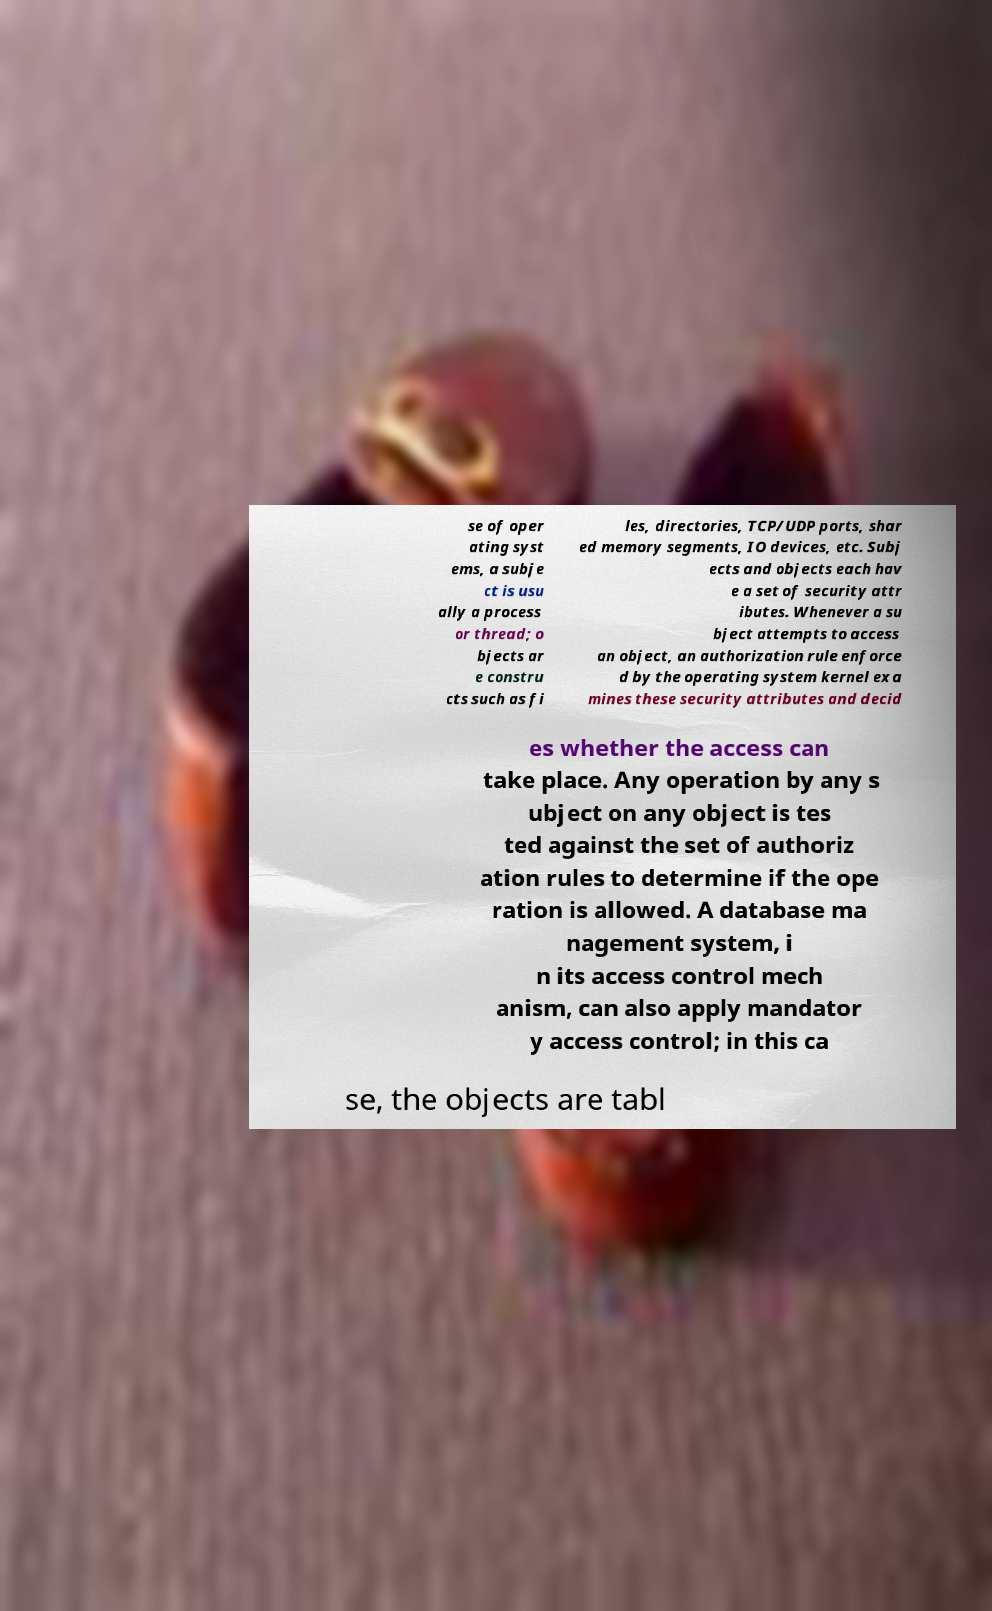Please identify and transcribe the text found in this image. se of oper ating syst ems, a subje ct is usu ally a process or thread; o bjects ar e constru cts such as fi les, directories, TCP/UDP ports, shar ed memory segments, IO devices, etc. Subj ects and objects each hav e a set of security attr ibutes. Whenever a su bject attempts to access an object, an authorization rule enforce d by the operating system kernel exa mines these security attributes and decid es whether the access can take place. Any operation by any s ubject on any object is tes ted against the set of authoriz ation rules to determine if the ope ration is allowed. A database ma nagement system, i n its access control mech anism, can also apply mandator y access control; in this ca se, the objects are tabl 